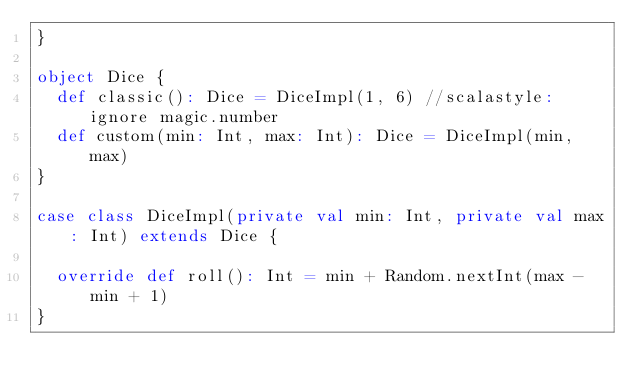Convert code to text. <code><loc_0><loc_0><loc_500><loc_500><_Scala_>}

object Dice {
  def classic(): Dice = DiceImpl(1, 6) //scalastyle:ignore magic.number
  def custom(min: Int, max: Int): Dice = DiceImpl(min, max)
}

case class DiceImpl(private val min: Int, private val max: Int) extends Dice {

  override def roll(): Int = min + Random.nextInt(max - min + 1)
}</code> 